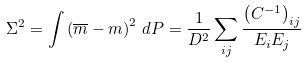<formula> <loc_0><loc_0><loc_500><loc_500>\Sigma ^ { 2 } = \int \left ( \overline { m } - m \right ) ^ { 2 } \, d P = \frac { 1 } { D ^ { 2 } } \sum _ { i j } \frac { \left ( C ^ { - 1 } \right ) _ { i j } } { E _ { i } E _ { j } }</formula> 